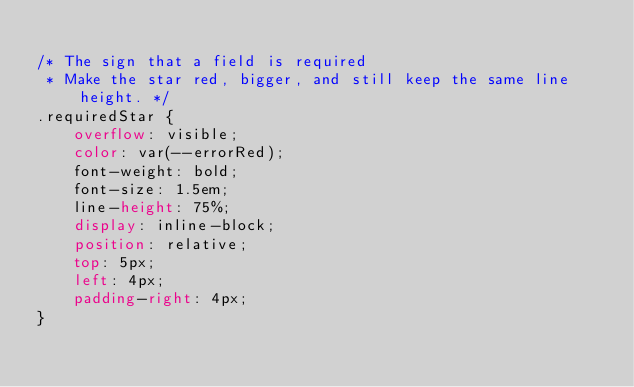<code> <loc_0><loc_0><loc_500><loc_500><_CSS_>
/* The sign that a field is required
 * Make the star red, bigger, and still keep the same line height. */
.requiredStar {
    overflow: visible;
    color: var(--errorRed);
    font-weight: bold;
    font-size: 1.5em;
    line-height: 75%;
    display: inline-block;
    position: relative;
    top: 5px;
    left: 4px;
    padding-right: 4px;
}
</code> 